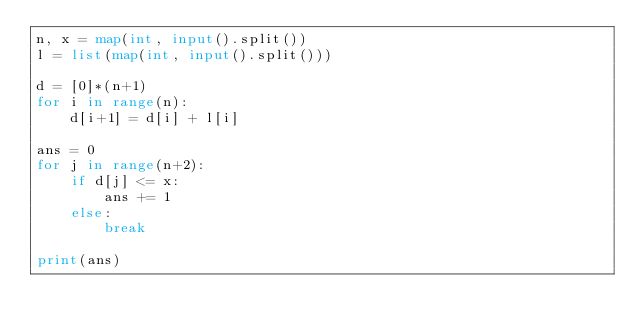Convert code to text. <code><loc_0><loc_0><loc_500><loc_500><_Python_>n, x = map(int, input().split())
l = list(map(int, input().split()))

d = [0]*(n+1)
for i in range(n):
    d[i+1] = d[i] + l[i]
    
ans = 0
for j in range(n+2):
    if d[j] <= x:
        ans += 1
    else:
        break

print(ans)</code> 